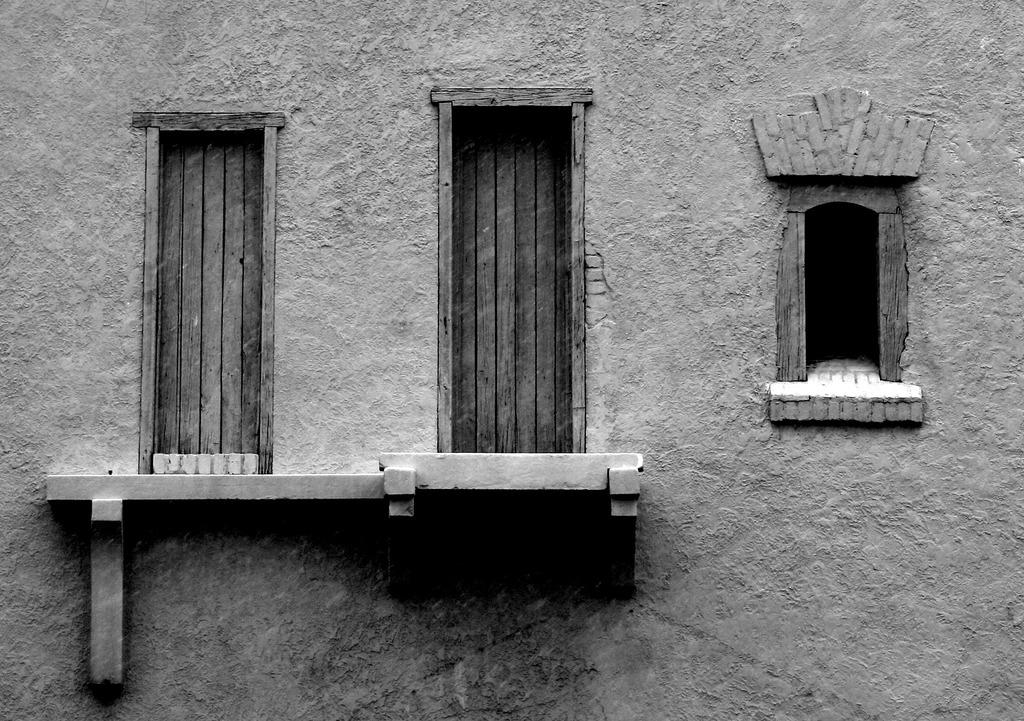Where was the image taken? The image was clicked outside. What is the main subject in the center of the image? There is a building in the center of the image. What feature of the building can be seen in the image? There are windows visible on the building. Can you describe any other objects or structures in the image? There is a shelf in the image. What type of ring can be seen on the building in the image? There is no ring present on the building in the image. Which direction is the building facing in the image? The provided facts do not mention the direction the building is facing, so it cannot be determined from the image. 